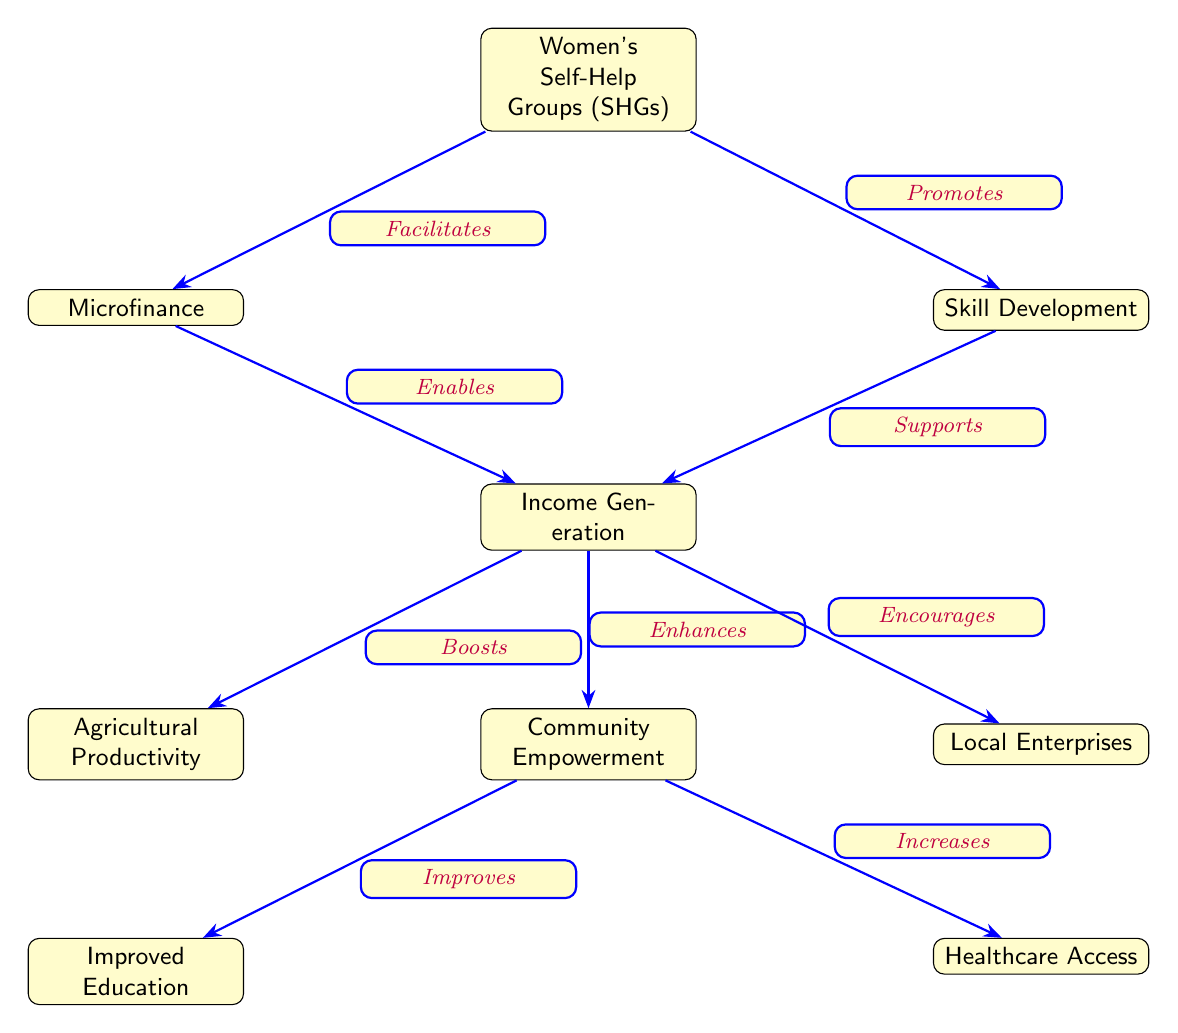What is the root node in the diagram? The root node is the main starting point of the diagram and represents the key concept of Women's Self-Help Groups (SHGs).
Answer: Women's Self-Help Groups (SHGs) How many nodes are there in the diagram? By counting all the distinct circles or boxes in the diagram, we find there are a total of nine nodes.
Answer: 9 What does Microfinance enable? In the diagram, Microfinance connects to Income Generation, which indicates that it enables people to generate income.
Answer: Income Generation Which node does the Skill Development promote? Skill Development flows towards Income Generation, indicating that it promotes this node.
Answer: Income Generation What are the outcomes of Community Empowerment? Community Empowerment leads to Improved Education and Healthcare Access, illustrating its dual outcomes.
Answer: Improved Education and Healthcare Access How many connections originate from the node Income Generation? The node Income Generation has two outgoing connections: one to Community Empowerment and another to Agricultural Productivity.
Answer: 2 What role does Women's Self-Help Groups (SHGs) play in relation to Microfinance? Women's Self-Help Groups (SHGs) facilitate Microfinance, indicating a supportive relationship where SHGs foster the conditions for microfinance opportunities.
Answer: Facilitates Which two nodes are directly influenced by Income Generation? From the diagram, Income Generation directly influences Community Empowerment and Local Enterprises, showcasing its wider impact.
Answer: Community Empowerment and Local Enterprises What benefits result from Income Generation? Income Generation enhances Community Empowerment, increases Agricultural Productivity, and encourages Local Enterprises, thus highlighting several key benefits.
Answer: Community Empowerment, Agricultural Productivity, Local Enterprises 